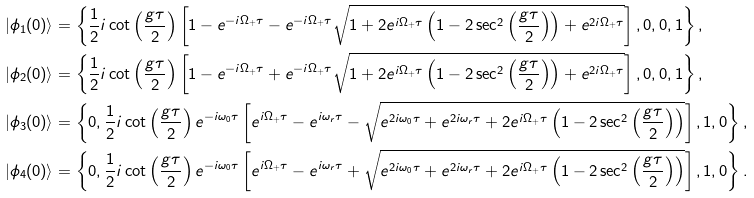<formula> <loc_0><loc_0><loc_500><loc_500>| \phi _ { 1 } ( 0 ) \rangle & = \left \{ \frac { 1 } { 2 } i \cot \left ( \frac { g \tau } { 2 } \right ) \left [ 1 - e ^ { - i \Omega _ { + } \tau } - e ^ { - i \Omega _ { + } \tau } \sqrt { 1 + 2 e ^ { i \Omega _ { + } \tau } \left ( 1 - 2 \sec ^ { 2 } \left ( \frac { g \tau } { 2 } \right ) \right ) + e ^ { 2 i \Omega _ { + } \tau } } \right ] , 0 , 0 , 1 \right \} , \\ | \phi _ { 2 } ( 0 ) \rangle & = \left \{ \frac { 1 } { 2 } i \cot \left ( \frac { g \tau } { 2 } \right ) \left [ 1 - e ^ { - i \Omega _ { + } \tau } + e ^ { - i \Omega _ { + } \tau } \sqrt { 1 + 2 e ^ { i \Omega _ { + } \tau } \left ( 1 - 2 \sec ^ { 2 } \left ( \frac { g \tau } { 2 } \right ) \right ) + e ^ { 2 i \Omega _ { + } \tau } } \right ] , 0 , 0 , 1 \right \} , \\ | \phi _ { 3 } ( 0 ) \rangle & = \left \{ 0 , \frac { 1 } { 2 } i \cot \left ( \frac { g \tau } { 2 } \right ) e ^ { - i \omega _ { 0 } \tau } \left [ e ^ { i \Omega _ { + } \tau } - e ^ { i \omega _ { r } \tau } - \sqrt { e ^ { 2 i \omega _ { 0 } \tau } + e ^ { 2 i \omega _ { r } \tau } + 2 e ^ { i \Omega _ { + } \tau } \left ( 1 - 2 \sec ^ { 2 } \left ( \frac { g \tau } { 2 } \right ) \right ) } \right ] , 1 , 0 \right \} , \\ | \phi _ { 4 } ( 0 ) \rangle & = \left \{ 0 , \frac { 1 } { 2 } i \cot \left ( \frac { g \tau } { 2 } \right ) e ^ { - i \omega _ { 0 } \tau } \left [ e ^ { i \Omega _ { + } \tau } - e ^ { i \omega _ { r } \tau } + \sqrt { e ^ { 2 i \omega _ { 0 } \tau } + e ^ { 2 i \omega _ { r } \tau } + 2 e ^ { i \Omega _ { + } \tau } \left ( 1 - 2 \sec ^ { 2 } \left ( \frac { g \tau } { 2 } \right ) \right ) } \right ] , 1 , 0 \right \} .</formula> 